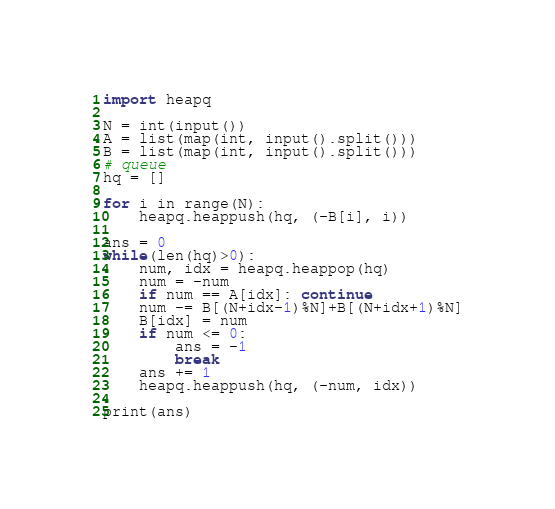<code> <loc_0><loc_0><loc_500><loc_500><_Python_>import heapq

N = int(input())
A = list(map(int, input().split()))
B = list(map(int, input().split()))
# queue
hq = []

for i in range(N):
    heapq.heappush(hq, (-B[i], i))

ans = 0
while(len(hq)>0):
    num, idx = heapq.heappop(hq)
    num = -num
    if num == A[idx]: continue
    num -= B[(N+idx-1)%N]+B[(N+idx+1)%N]
    B[idx] = num
    if num <= 0:
        ans = -1
        break
    ans += 1
    heapq.heappush(hq, (-num, idx))

print(ans)</code> 